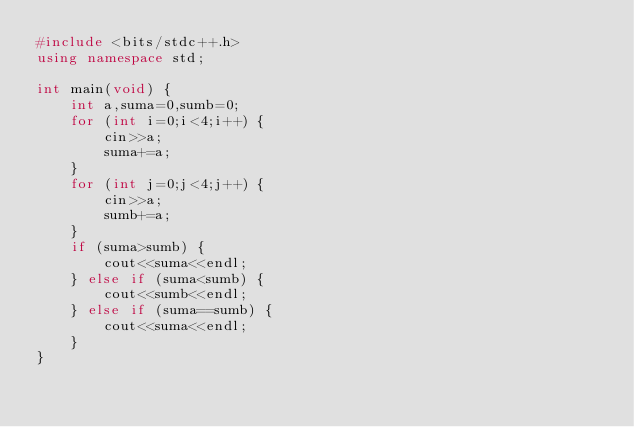<code> <loc_0><loc_0><loc_500><loc_500><_C++_>#include <bits/stdc++.h>
using namespace std;

int main(void) {
    int a,suma=0,sumb=0;
    for (int i=0;i<4;i++) {
        cin>>a;
        suma+=a;
    }
    for (int j=0;j<4;j++) {
        cin>>a;
        sumb+=a;
    }
    if (suma>sumb) {
        cout<<suma<<endl;
    } else if (suma<sumb) {
        cout<<sumb<<endl;
    } else if (suma==sumb) {
        cout<<suma<<endl;
    }
}
</code> 